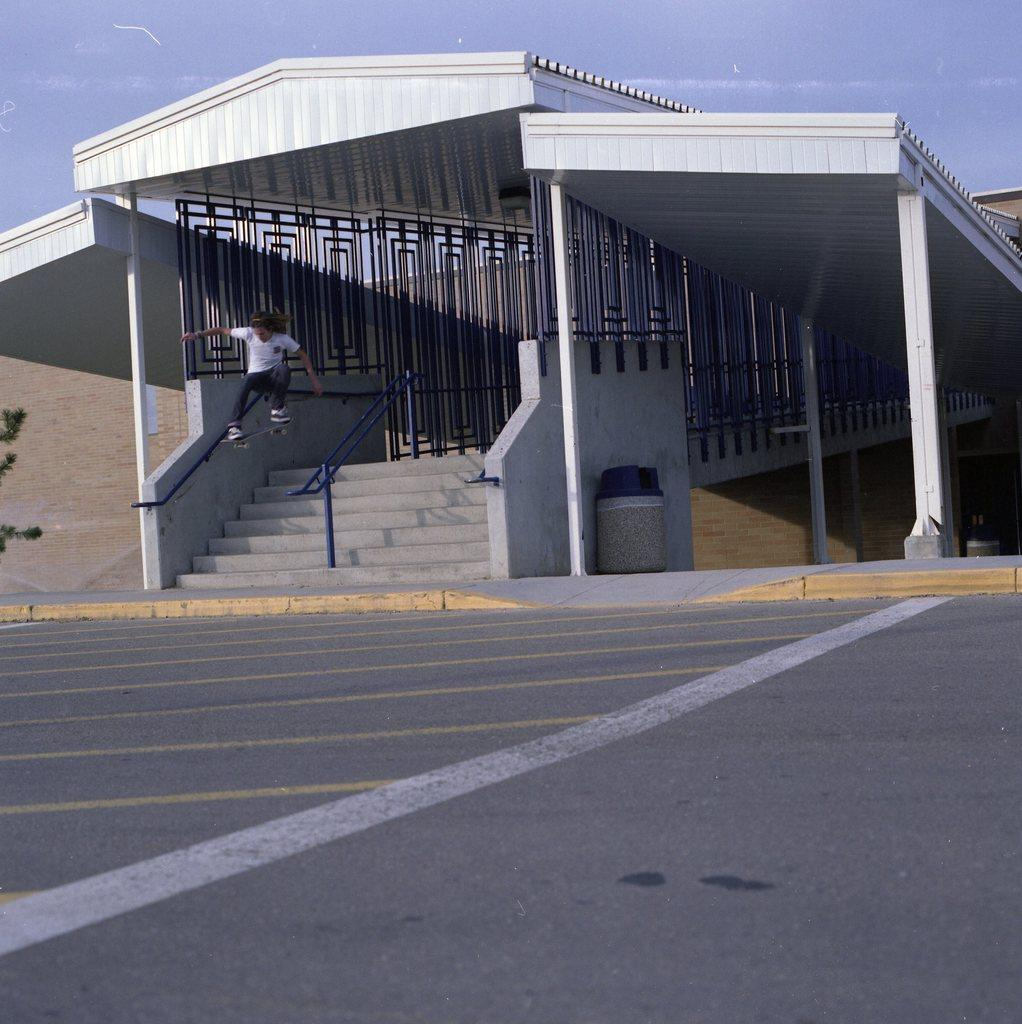What can be seen at the top of the image? The sky is visible at the top of the image. What type of structure is present in the image? There is an open shed with railing in the image. Where is the trash can located in the image? The trash can is near a wall in the image. What is the person with a skateboard doing in the image? The person with a skateboard is in the air in the image. What type of surface is visible in the image? There is a road in the image. What type of milk is being poured into the cheese in the image? There is no milk or cheese present in the image. 